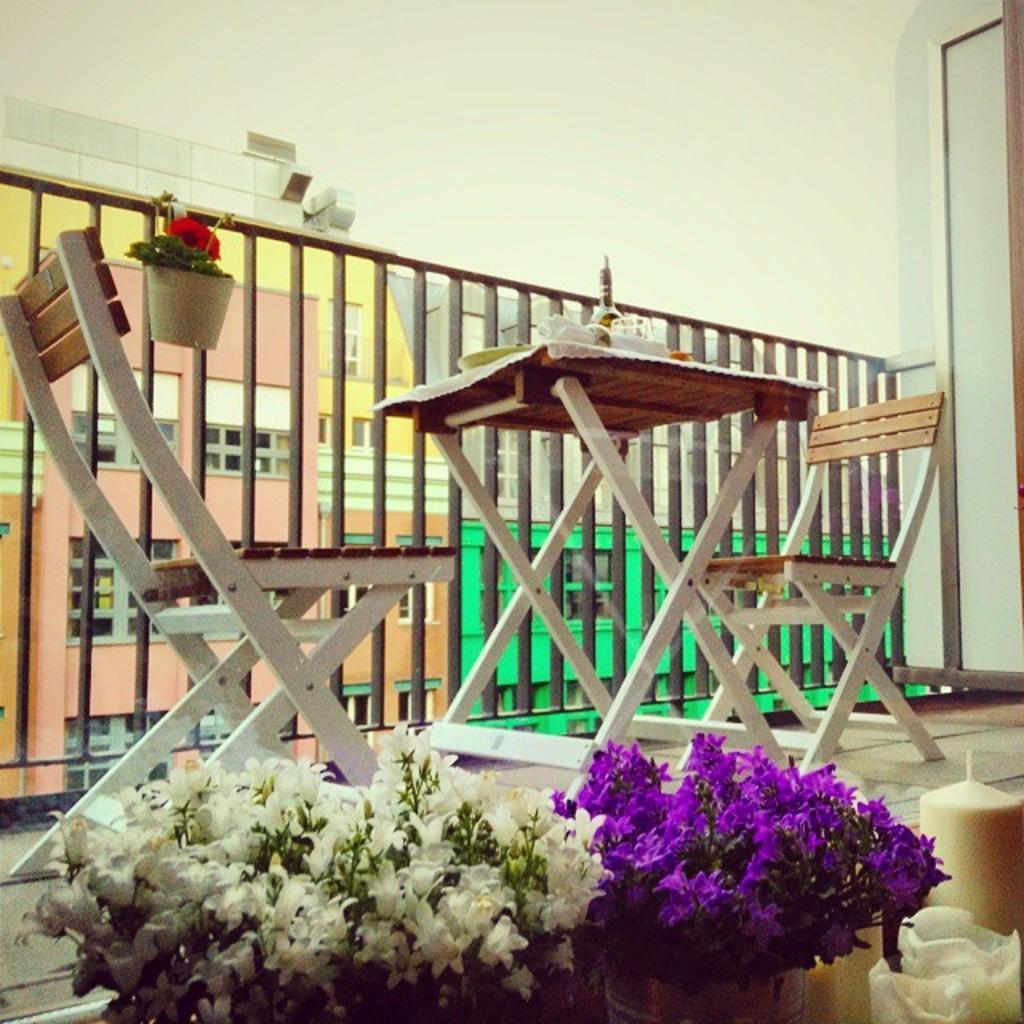Please provide a concise description of this image. In this image there are flowers pots with white, purple and red flowers. There is a plate, glass on the table, table is covered with white cloth. There are two chairs. At the back there is a building, at the top there is a sky. 